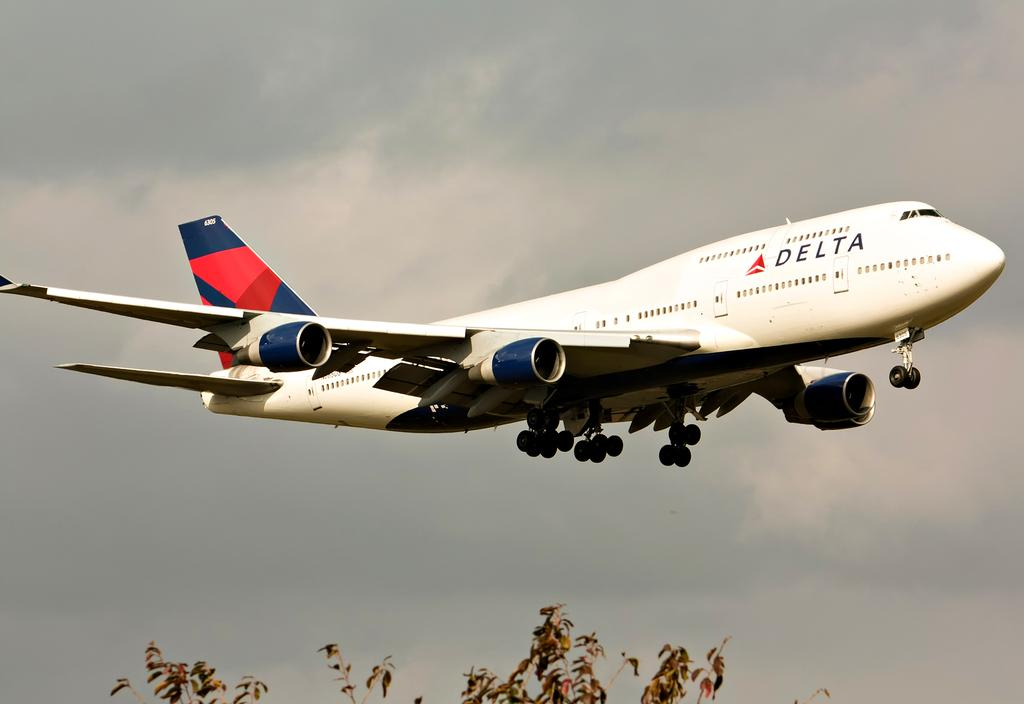<image>
Render a clear and concise summary of the photo. the word Delta that is on a plane 